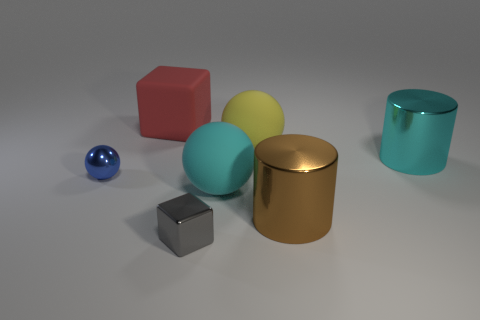Is the number of big cyan cylinders that are in front of the small metallic sphere less than the number of big brown matte balls?
Offer a very short reply. No. Is there any other thing that is the same shape as the tiny gray metal object?
Provide a succinct answer. Yes. The tiny thing to the right of the red rubber thing has what shape?
Ensure brevity in your answer.  Cube. What is the shape of the blue metallic thing that is behind the large cyan ball that is in front of the big cyan thing behind the large cyan ball?
Your answer should be compact. Sphere. How many objects are either yellow matte cylinders or large rubber balls?
Provide a succinct answer. 2. There is a small thing right of the tiny blue thing; does it have the same shape as the matte object in front of the blue object?
Provide a short and direct response. No. How many objects are left of the brown cylinder and in front of the tiny blue ball?
Make the answer very short. 2. How many other things are there of the same size as the yellow thing?
Provide a succinct answer. 4. There is a thing that is to the left of the gray metal block and to the right of the blue metal object; what is it made of?
Your response must be concise. Rubber. Do the metallic sphere and the big cylinder that is behind the big brown metallic cylinder have the same color?
Your answer should be compact. No. 